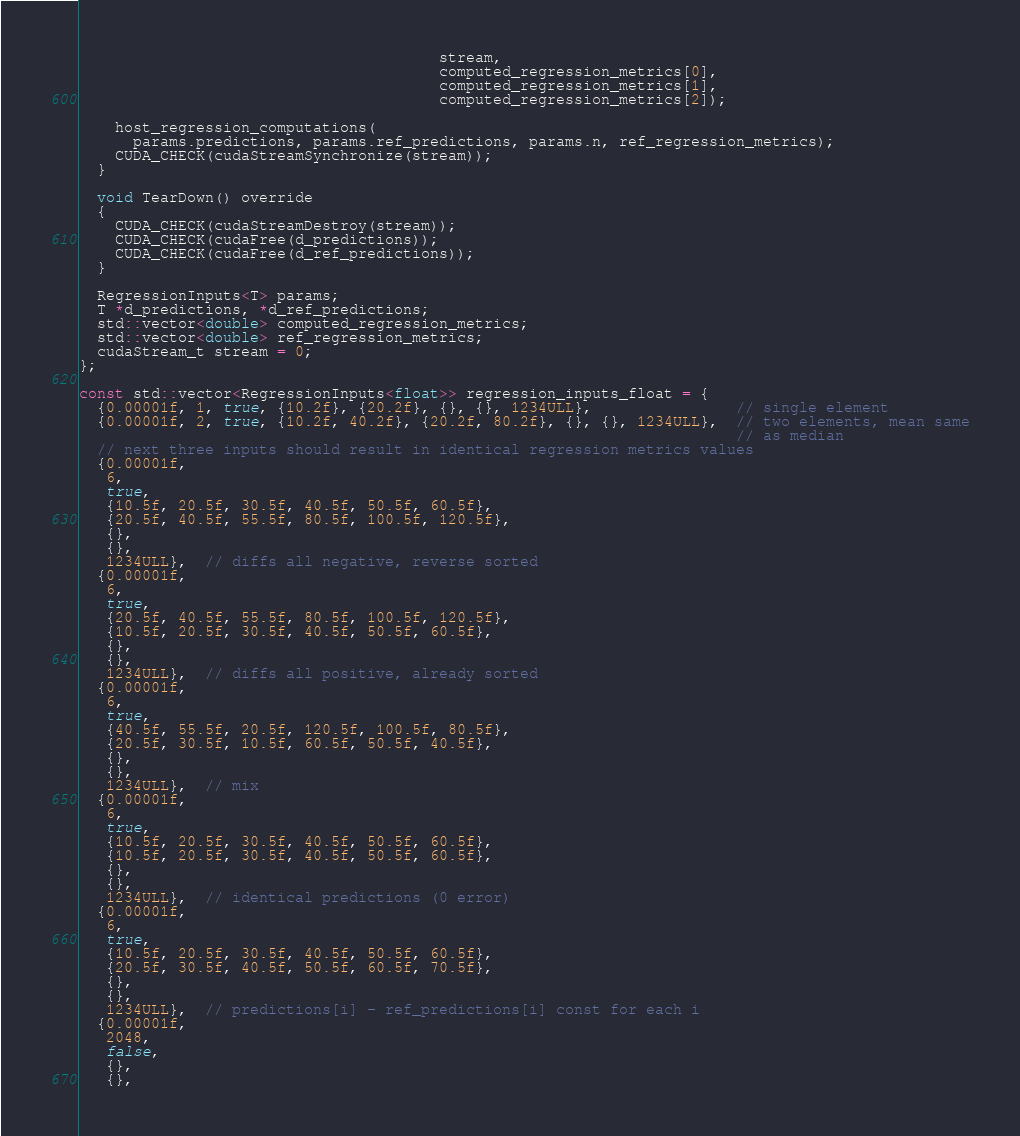Convert code to text. <code><loc_0><loc_0><loc_500><loc_500><_Cuda_>                                        stream,
                                        computed_regression_metrics[0],
                                        computed_regression_metrics[1],
                                        computed_regression_metrics[2]);

    host_regression_computations(
      params.predictions, params.ref_predictions, params.n, ref_regression_metrics);
    CUDA_CHECK(cudaStreamSynchronize(stream));
  }

  void TearDown() override
  {
    CUDA_CHECK(cudaStreamDestroy(stream));
    CUDA_CHECK(cudaFree(d_predictions));
    CUDA_CHECK(cudaFree(d_ref_predictions));
  }

  RegressionInputs<T> params;
  T *d_predictions, *d_ref_predictions;
  std::vector<double> computed_regression_metrics;
  std::vector<double> ref_regression_metrics;
  cudaStream_t stream = 0;
};

const std::vector<RegressionInputs<float>> regression_inputs_float = {
  {0.00001f, 1, true, {10.2f}, {20.2f}, {}, {}, 1234ULL},                // single element
  {0.00001f, 2, true, {10.2f, 40.2f}, {20.2f, 80.2f}, {}, {}, 1234ULL},  // two elements, mean same
                                                                         // as median
  // next three inputs should result in identical regression metrics values
  {0.00001f,
   6,
   true,
   {10.5f, 20.5f, 30.5f, 40.5f, 50.5f, 60.5f},
   {20.5f, 40.5f, 55.5f, 80.5f, 100.5f, 120.5f},
   {},
   {},
   1234ULL},  // diffs all negative, reverse sorted
  {0.00001f,
   6,
   true,
   {20.5f, 40.5f, 55.5f, 80.5f, 100.5f, 120.5f},
   {10.5f, 20.5f, 30.5f, 40.5f, 50.5f, 60.5f},
   {},
   {},
   1234ULL},  // diffs all positive, already sorted
  {0.00001f,
   6,
   true,
   {40.5f, 55.5f, 20.5f, 120.5f, 100.5f, 80.5f},
   {20.5f, 30.5f, 10.5f, 60.5f, 50.5f, 40.5f},
   {},
   {},
   1234ULL},  // mix
  {0.00001f,
   6,
   true,
   {10.5f, 20.5f, 30.5f, 40.5f, 50.5f, 60.5f},
   {10.5f, 20.5f, 30.5f, 40.5f, 50.5f, 60.5f},
   {},
   {},
   1234ULL},  // identical predictions (0 error)
  {0.00001f,
   6,
   true,
   {10.5f, 20.5f, 30.5f, 40.5f, 50.5f, 60.5f},
   {20.5f, 30.5f, 40.5f, 50.5f, 60.5f, 70.5f},
   {},
   {},
   1234ULL},  // predictions[i] - ref_predictions[i] const for each i
  {0.00001f,
   2048,
   false,
   {},
   {},</code> 